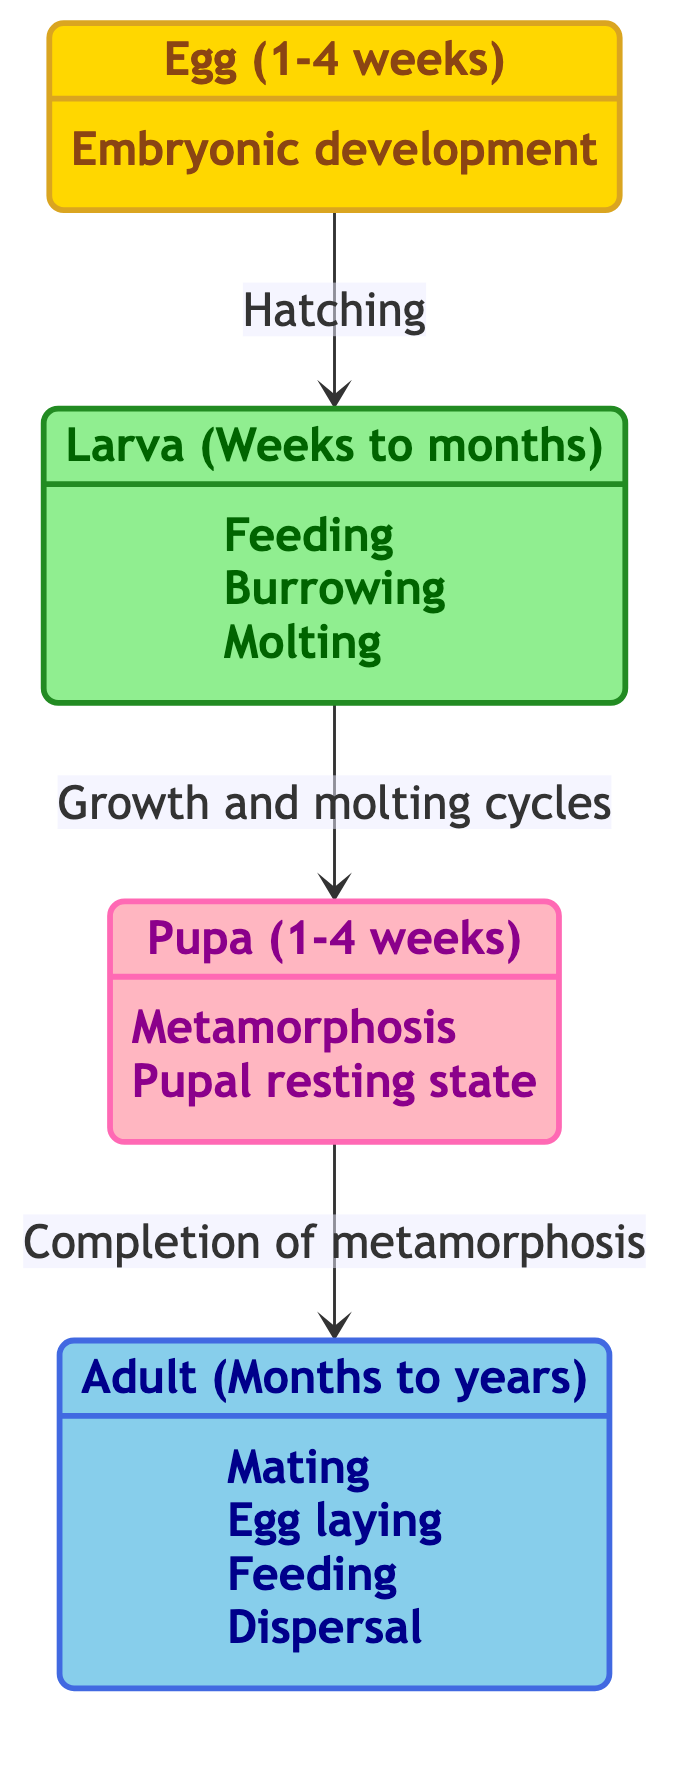What is the starting stage of a beetle's lifecycle? The starting stage of the lifecycle, as indicated in the diagram, is labeled "Egg."
Answer: Egg How many lifecycle stages are depicted in the diagram? The diagram shows four distinct lifecycle stages: Egg, Larva, Pupa, and Adult.
Answer: Four What is the transition from Larva to Pupa triggered by? The transition is triggered by "Growth and molting cycles," which indicates a specific developmental process the larva undergoes before becoming a pupa.
Answer: Growth and molting cycles What behavior is associated with the Adult stage? Among various behaviors, one of the key behaviors associated with the Adult stage is "Mating," which indicates a phase focused on reproduction.
Answer: Mating What is the typical duration for the Pupa stage? The diagram specifies that the typical duration for the Pupa stage is between "1-4 weeks."
Answer: 1-4 weeks Which lifecycle stage comes directly after the Egg stage? The stage directly following the Egg stage, as illustrated by the transition indicated in the diagram, is the Larva stage.
Answer: Larva What triggers the transition from Pupa to Adult? The transition from Pupa to Adult is triggered by the "Completion of metamorphosis," indicating that the pupa has fully developed into an adult beetle.
Answer: Completion of metamorphosis How long can the Adult stage last depending on the species? The diagram indicates that the Adult stage can last "Several months to years, depending on species," emphasizing variability across different beetle types.
Answer: Several months to years What is a possible behavior of the Larva stage? One possible behavior of the Larva stage is "Feeding on organic material," which reflects its role in consuming nutrients for growth.
Answer: Feeding on organic material 